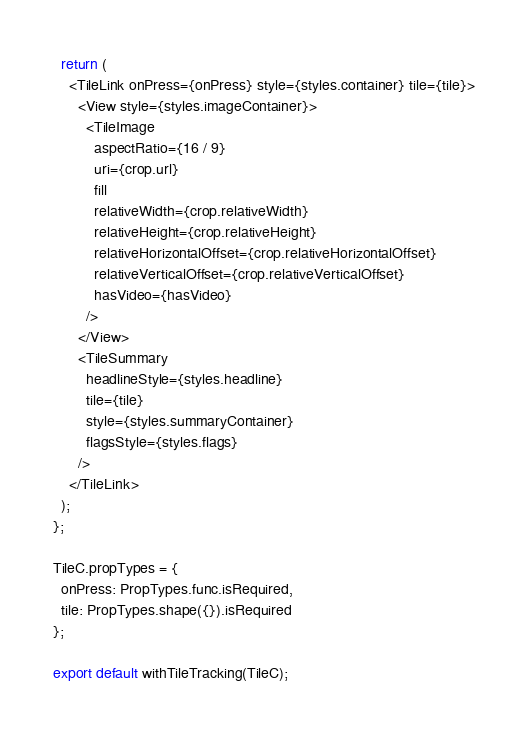<code> <loc_0><loc_0><loc_500><loc_500><_JavaScript_>  return (
    <TileLink onPress={onPress} style={styles.container} tile={tile}>
      <View style={styles.imageContainer}>
        <TileImage
          aspectRatio={16 / 9}
          uri={crop.url}
          fill
          relativeWidth={crop.relativeWidth}
          relativeHeight={crop.relativeHeight}
          relativeHorizontalOffset={crop.relativeHorizontalOffset}
          relativeVerticalOffset={crop.relativeVerticalOffset}
          hasVideo={hasVideo}
        />
      </View>
      <TileSummary
        headlineStyle={styles.headline}
        tile={tile}
        style={styles.summaryContainer}
        flagsStyle={styles.flags}
      />
    </TileLink>
  );
};

TileC.propTypes = {
  onPress: PropTypes.func.isRequired,
  tile: PropTypes.shape({}).isRequired
};

export default withTileTracking(TileC);
</code> 